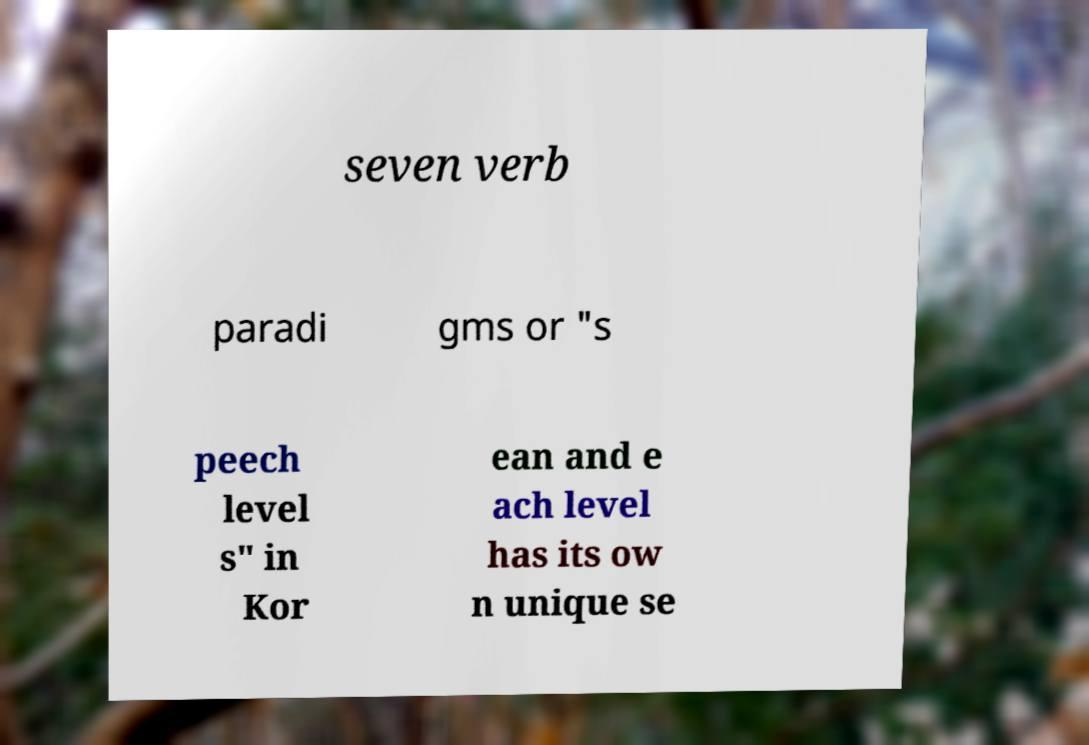I need the written content from this picture converted into text. Can you do that? seven verb paradi gms or "s peech level s" in Kor ean and e ach level has its ow n unique se 